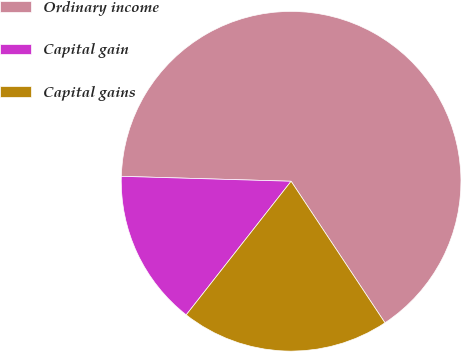Convert chart. <chart><loc_0><loc_0><loc_500><loc_500><pie_chart><fcel>Ordinary income<fcel>Capital gain<fcel>Capital gains<nl><fcel>65.22%<fcel>14.87%<fcel>19.91%<nl></chart> 